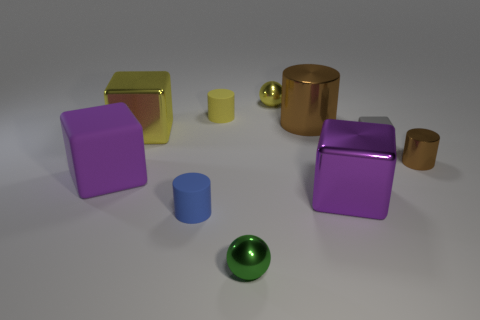Are there any green metal balls of the same size as the yellow shiny cube?
Your answer should be compact. No. There is a brown cylinder that is the same size as the gray thing; what is its material?
Your answer should be very brief. Metal. There is a shiny object that is on the left side of the small yellow ball and in front of the large rubber object; what shape is it?
Keep it short and to the point. Sphere. What is the color of the rubber object on the right side of the small green thing?
Make the answer very short. Gray. There is a cylinder that is both in front of the tiny gray rubber thing and right of the tiny yellow rubber object; what size is it?
Offer a terse response. Small. Do the small green ball and the block behind the gray matte cube have the same material?
Your answer should be compact. Yes. What number of small brown objects have the same shape as the blue object?
Give a very brief answer. 1. There is a tiny cylinder that is the same color as the large cylinder; what is its material?
Provide a short and direct response. Metal. How many tiny matte objects are there?
Provide a short and direct response. 3. There is a big rubber thing; is its shape the same as the tiny gray rubber thing that is right of the purple metallic thing?
Give a very brief answer. Yes. 